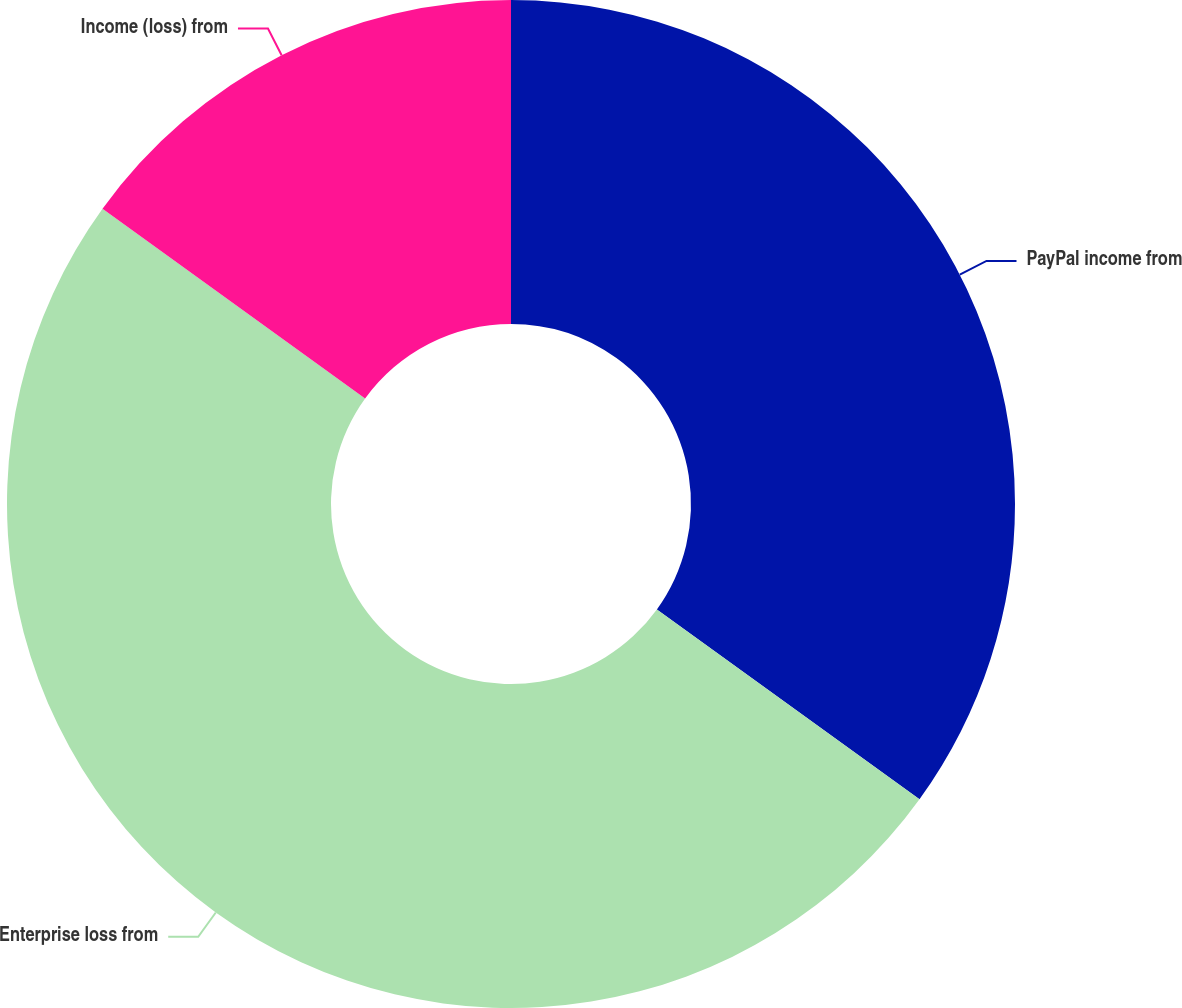Convert chart to OTSL. <chart><loc_0><loc_0><loc_500><loc_500><pie_chart><fcel>PayPal income from<fcel>Enterprise loss from<fcel>Income (loss) from<nl><fcel>34.96%<fcel>50.0%<fcel>15.04%<nl></chart> 